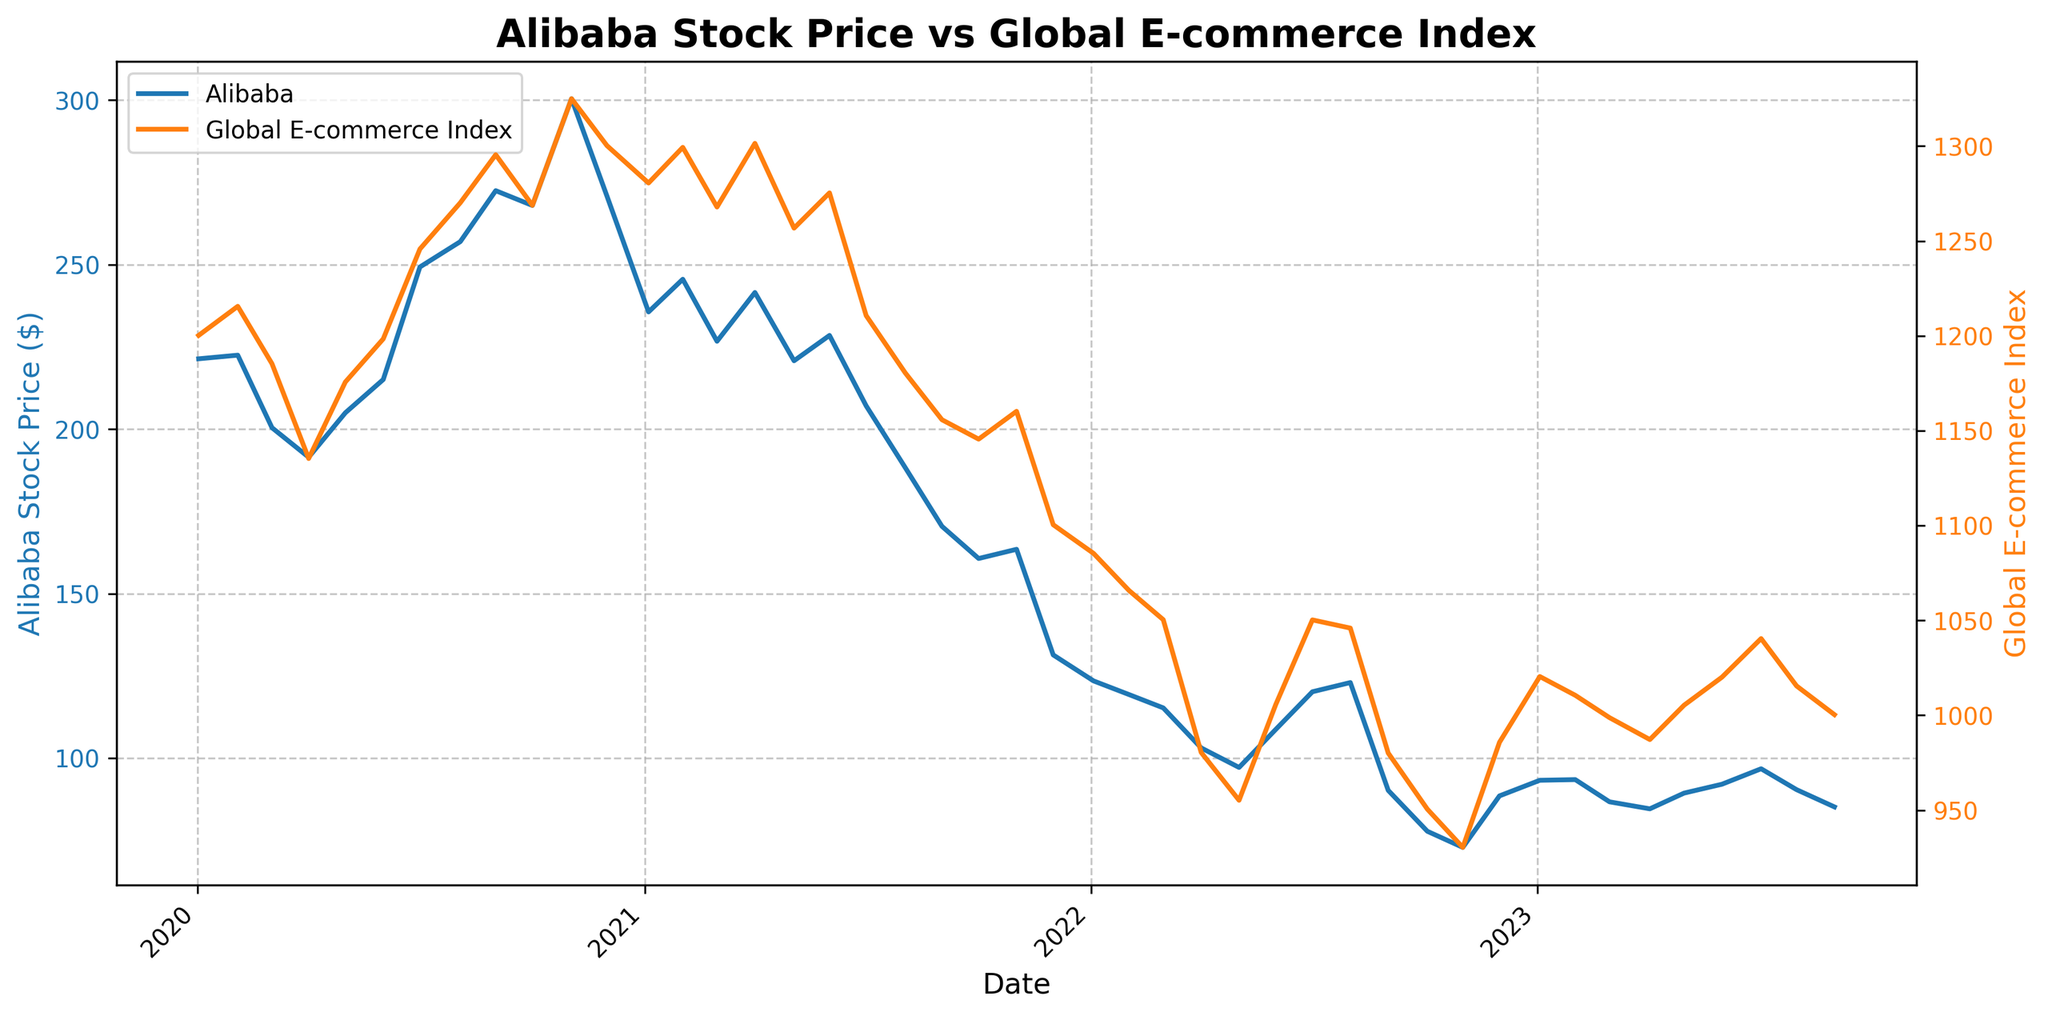What is the title of the figure? The title is typically located at the top of the figure and provides a summary of what the plot is about. By simply reading the text at the top, we can identify the title.
Answer: Alibaba Stock Price vs Global E-commerce Index What is the color of the line representing Alibaba's stock price? The color of the line representing Alibaba's stock price can be discerned by looking at the plot's legend or the line color itself.
Answer: Blue How many data points are plotted for Alibaba's stock price? By counting the number of distinct points where the line for Alibaba's stock price changes direction, we can determine the number of data points plotted.
Answer: 37 What is the maximum value reached by Alibaba's stock price? To find the maximum value, look at the highest point on the blue line representing Alibaba's stock price. The y-axis for Alibaba’s stock price will guide you to the exact value.
Answer: 300.45 How does Alibaba's stock price in July 2020 compare to its price in July 2021? Identify the July 2020 and July 2021 points on the x-axis, and then compare the corresponding y-axis values for Alibaba's stock price.
Answer: Higher in July 2020 By how much did Alibaba's stock price decrease from November 2020 to January 2021? Determine the values of Alibaba's stock price in November 2020 and January 2021 from the y-axis and subtract the January 2021 value from the November 2020 value.
Answer: 64.80 How does the trend of Alibaba's stock price in 2022 compare to the trend in the Global E-commerce Index for the same period? Examine the overall direction (increasing or decreasing) of both lines in 2022. The trend can be identified by looking at the start and end points within 2022.
Answer: Both decrease What was the Global E-commerce Index value when Alibaba's stock reached its peak? Find the peak value of Alibaba's stock price and then trace the corresponding date onto the Global E-commerce Index line to find its value.
Answer: 1324.98 What was the percentage drop in Alibaba's stock price from January 2021 to December 2021? Calculate the difference in stock price between January 2021 and December 2021, divide by the January 2021 price, and multiply by 100 to get the percentage.
Answer: ≈ 44.23% When was the steepest decline in Alibaba's stock price observed, and approximately how much was the decrease? Look for the part of the blue line where the drop is visually the steepest, then find the start and end dates and corresponding values to calculate the decrease.
Answer: December 2021, ≈ 41.45 